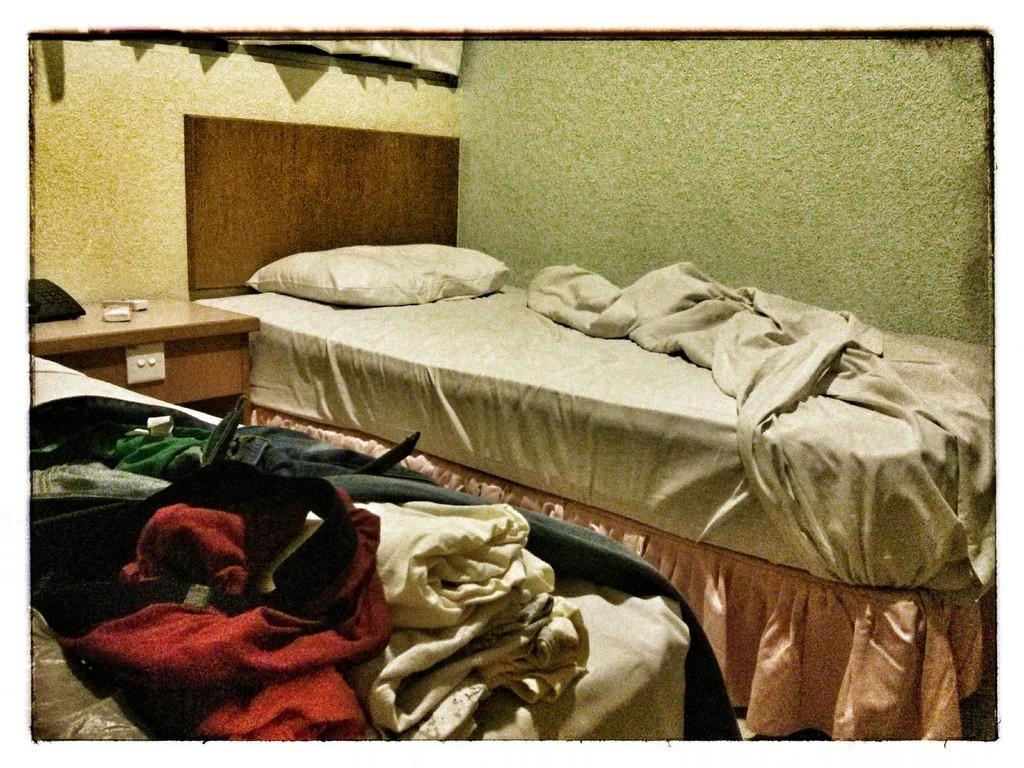Please provide a concise description of this image. in a room there are 2 beds. on the left bed there are clothes. on the right bed there is a white pillow and a white bed sheet. in between them there is a table. behind that there is a wall and above that there are curtains. 